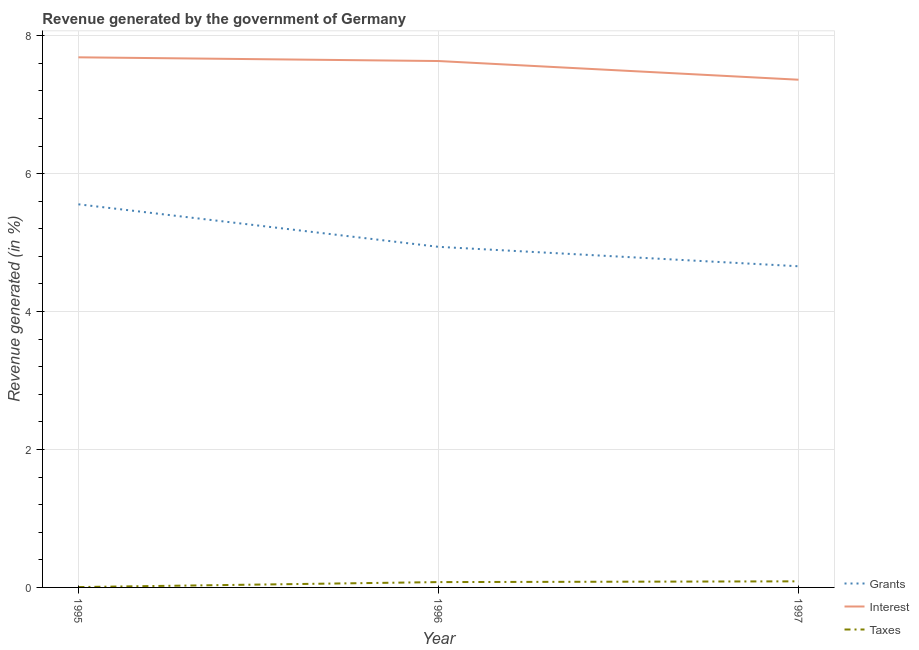What is the percentage of revenue generated by interest in 1996?
Your answer should be compact. 7.63. Across all years, what is the maximum percentage of revenue generated by interest?
Provide a short and direct response. 7.69. Across all years, what is the minimum percentage of revenue generated by grants?
Ensure brevity in your answer.  4.66. What is the total percentage of revenue generated by interest in the graph?
Provide a succinct answer. 22.68. What is the difference between the percentage of revenue generated by taxes in 1996 and that in 1997?
Keep it short and to the point. -0.01. What is the difference between the percentage of revenue generated by interest in 1997 and the percentage of revenue generated by taxes in 1995?
Ensure brevity in your answer.  7.36. What is the average percentage of revenue generated by grants per year?
Offer a very short reply. 5.05. In the year 1996, what is the difference between the percentage of revenue generated by taxes and percentage of revenue generated by grants?
Offer a terse response. -4.86. What is the ratio of the percentage of revenue generated by taxes in 1995 to that in 1996?
Your answer should be very brief. 0.07. Is the difference between the percentage of revenue generated by grants in 1996 and 1997 greater than the difference between the percentage of revenue generated by taxes in 1996 and 1997?
Provide a short and direct response. Yes. What is the difference between the highest and the second highest percentage of revenue generated by grants?
Ensure brevity in your answer.  0.62. What is the difference between the highest and the lowest percentage of revenue generated by grants?
Make the answer very short. 0.9. Is it the case that in every year, the sum of the percentage of revenue generated by grants and percentage of revenue generated by interest is greater than the percentage of revenue generated by taxes?
Offer a terse response. Yes. Is the percentage of revenue generated by interest strictly greater than the percentage of revenue generated by taxes over the years?
Your answer should be very brief. Yes. Is the percentage of revenue generated by taxes strictly less than the percentage of revenue generated by grants over the years?
Your answer should be compact. Yes. How many lines are there?
Your response must be concise. 3. What is the difference between two consecutive major ticks on the Y-axis?
Your response must be concise. 2. Does the graph contain any zero values?
Offer a very short reply. No. Does the graph contain grids?
Make the answer very short. Yes. Where does the legend appear in the graph?
Your response must be concise. Bottom right. How many legend labels are there?
Keep it short and to the point. 3. How are the legend labels stacked?
Keep it short and to the point. Vertical. What is the title of the graph?
Give a very brief answer. Revenue generated by the government of Germany. What is the label or title of the X-axis?
Offer a very short reply. Year. What is the label or title of the Y-axis?
Make the answer very short. Revenue generated (in %). What is the Revenue generated (in %) of Grants in 1995?
Offer a terse response. 5.55. What is the Revenue generated (in %) of Interest in 1995?
Provide a succinct answer. 7.69. What is the Revenue generated (in %) of Taxes in 1995?
Ensure brevity in your answer.  0.01. What is the Revenue generated (in %) of Grants in 1996?
Your response must be concise. 4.94. What is the Revenue generated (in %) of Interest in 1996?
Your answer should be compact. 7.63. What is the Revenue generated (in %) in Taxes in 1996?
Provide a short and direct response. 0.08. What is the Revenue generated (in %) in Grants in 1997?
Make the answer very short. 4.66. What is the Revenue generated (in %) in Interest in 1997?
Give a very brief answer. 7.36. What is the Revenue generated (in %) of Taxes in 1997?
Provide a succinct answer. 0.09. Across all years, what is the maximum Revenue generated (in %) in Grants?
Provide a succinct answer. 5.55. Across all years, what is the maximum Revenue generated (in %) in Interest?
Make the answer very short. 7.69. Across all years, what is the maximum Revenue generated (in %) of Taxes?
Your response must be concise. 0.09. Across all years, what is the minimum Revenue generated (in %) of Grants?
Offer a very short reply. 4.66. Across all years, what is the minimum Revenue generated (in %) in Interest?
Your response must be concise. 7.36. Across all years, what is the minimum Revenue generated (in %) in Taxes?
Your answer should be very brief. 0.01. What is the total Revenue generated (in %) in Grants in the graph?
Make the answer very short. 15.15. What is the total Revenue generated (in %) in Interest in the graph?
Make the answer very short. 22.68. What is the total Revenue generated (in %) in Taxes in the graph?
Keep it short and to the point. 0.17. What is the difference between the Revenue generated (in %) of Grants in 1995 and that in 1996?
Ensure brevity in your answer.  0.62. What is the difference between the Revenue generated (in %) in Interest in 1995 and that in 1996?
Your response must be concise. 0.05. What is the difference between the Revenue generated (in %) in Taxes in 1995 and that in 1996?
Ensure brevity in your answer.  -0.07. What is the difference between the Revenue generated (in %) of Grants in 1995 and that in 1997?
Keep it short and to the point. 0.9. What is the difference between the Revenue generated (in %) in Interest in 1995 and that in 1997?
Ensure brevity in your answer.  0.32. What is the difference between the Revenue generated (in %) of Taxes in 1995 and that in 1997?
Your response must be concise. -0.08. What is the difference between the Revenue generated (in %) in Grants in 1996 and that in 1997?
Make the answer very short. 0.28. What is the difference between the Revenue generated (in %) of Interest in 1996 and that in 1997?
Make the answer very short. 0.27. What is the difference between the Revenue generated (in %) of Taxes in 1996 and that in 1997?
Your answer should be compact. -0.01. What is the difference between the Revenue generated (in %) in Grants in 1995 and the Revenue generated (in %) in Interest in 1996?
Give a very brief answer. -2.08. What is the difference between the Revenue generated (in %) in Grants in 1995 and the Revenue generated (in %) in Taxes in 1996?
Make the answer very short. 5.48. What is the difference between the Revenue generated (in %) of Interest in 1995 and the Revenue generated (in %) of Taxes in 1996?
Offer a very short reply. 7.61. What is the difference between the Revenue generated (in %) of Grants in 1995 and the Revenue generated (in %) of Interest in 1997?
Provide a short and direct response. -1.81. What is the difference between the Revenue generated (in %) in Grants in 1995 and the Revenue generated (in %) in Taxes in 1997?
Give a very brief answer. 5.47. What is the difference between the Revenue generated (in %) in Interest in 1995 and the Revenue generated (in %) in Taxes in 1997?
Offer a terse response. 7.6. What is the difference between the Revenue generated (in %) in Grants in 1996 and the Revenue generated (in %) in Interest in 1997?
Make the answer very short. -2.42. What is the difference between the Revenue generated (in %) in Grants in 1996 and the Revenue generated (in %) in Taxes in 1997?
Provide a succinct answer. 4.85. What is the difference between the Revenue generated (in %) in Interest in 1996 and the Revenue generated (in %) in Taxes in 1997?
Your answer should be very brief. 7.54. What is the average Revenue generated (in %) in Grants per year?
Provide a short and direct response. 5.05. What is the average Revenue generated (in %) of Interest per year?
Give a very brief answer. 7.56. What is the average Revenue generated (in %) of Taxes per year?
Offer a terse response. 0.06. In the year 1995, what is the difference between the Revenue generated (in %) in Grants and Revenue generated (in %) in Interest?
Provide a short and direct response. -2.13. In the year 1995, what is the difference between the Revenue generated (in %) in Grants and Revenue generated (in %) in Taxes?
Your response must be concise. 5.55. In the year 1995, what is the difference between the Revenue generated (in %) of Interest and Revenue generated (in %) of Taxes?
Make the answer very short. 7.68. In the year 1996, what is the difference between the Revenue generated (in %) of Grants and Revenue generated (in %) of Interest?
Your answer should be compact. -2.69. In the year 1996, what is the difference between the Revenue generated (in %) of Grants and Revenue generated (in %) of Taxes?
Your answer should be compact. 4.86. In the year 1996, what is the difference between the Revenue generated (in %) in Interest and Revenue generated (in %) in Taxes?
Your response must be concise. 7.55. In the year 1997, what is the difference between the Revenue generated (in %) in Grants and Revenue generated (in %) in Interest?
Your answer should be compact. -2.7. In the year 1997, what is the difference between the Revenue generated (in %) in Grants and Revenue generated (in %) in Taxes?
Provide a short and direct response. 4.57. In the year 1997, what is the difference between the Revenue generated (in %) in Interest and Revenue generated (in %) in Taxes?
Make the answer very short. 7.27. What is the ratio of the Revenue generated (in %) in Grants in 1995 to that in 1996?
Offer a terse response. 1.12. What is the ratio of the Revenue generated (in %) in Interest in 1995 to that in 1996?
Provide a succinct answer. 1.01. What is the ratio of the Revenue generated (in %) of Taxes in 1995 to that in 1996?
Offer a terse response. 0.07. What is the ratio of the Revenue generated (in %) in Grants in 1995 to that in 1997?
Give a very brief answer. 1.19. What is the ratio of the Revenue generated (in %) in Interest in 1995 to that in 1997?
Offer a terse response. 1.04. What is the ratio of the Revenue generated (in %) in Taxes in 1995 to that in 1997?
Make the answer very short. 0.06. What is the ratio of the Revenue generated (in %) in Grants in 1996 to that in 1997?
Offer a very short reply. 1.06. What is the ratio of the Revenue generated (in %) in Interest in 1996 to that in 1997?
Keep it short and to the point. 1.04. What is the ratio of the Revenue generated (in %) in Taxes in 1996 to that in 1997?
Provide a short and direct response. 0.88. What is the difference between the highest and the second highest Revenue generated (in %) of Grants?
Give a very brief answer. 0.62. What is the difference between the highest and the second highest Revenue generated (in %) in Interest?
Your answer should be very brief. 0.05. What is the difference between the highest and the second highest Revenue generated (in %) in Taxes?
Provide a short and direct response. 0.01. What is the difference between the highest and the lowest Revenue generated (in %) in Grants?
Your response must be concise. 0.9. What is the difference between the highest and the lowest Revenue generated (in %) of Interest?
Provide a short and direct response. 0.32. What is the difference between the highest and the lowest Revenue generated (in %) of Taxes?
Give a very brief answer. 0.08. 